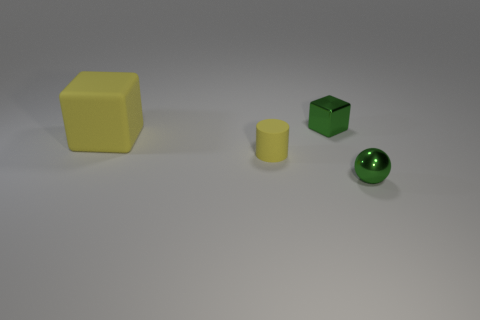Add 1 small blue metal cubes. How many objects exist? 5 Add 4 brown metallic things. How many brown metallic things exist? 4 Subtract all yellow blocks. How many blocks are left? 1 Subtract 0 brown cylinders. How many objects are left? 4 Subtract all spheres. How many objects are left? 3 Subtract all brown spheres. Subtract all gray blocks. How many spheres are left? 1 Subtract all small cyan matte balls. Subtract all small rubber cylinders. How many objects are left? 3 Add 1 yellow objects. How many yellow objects are left? 3 